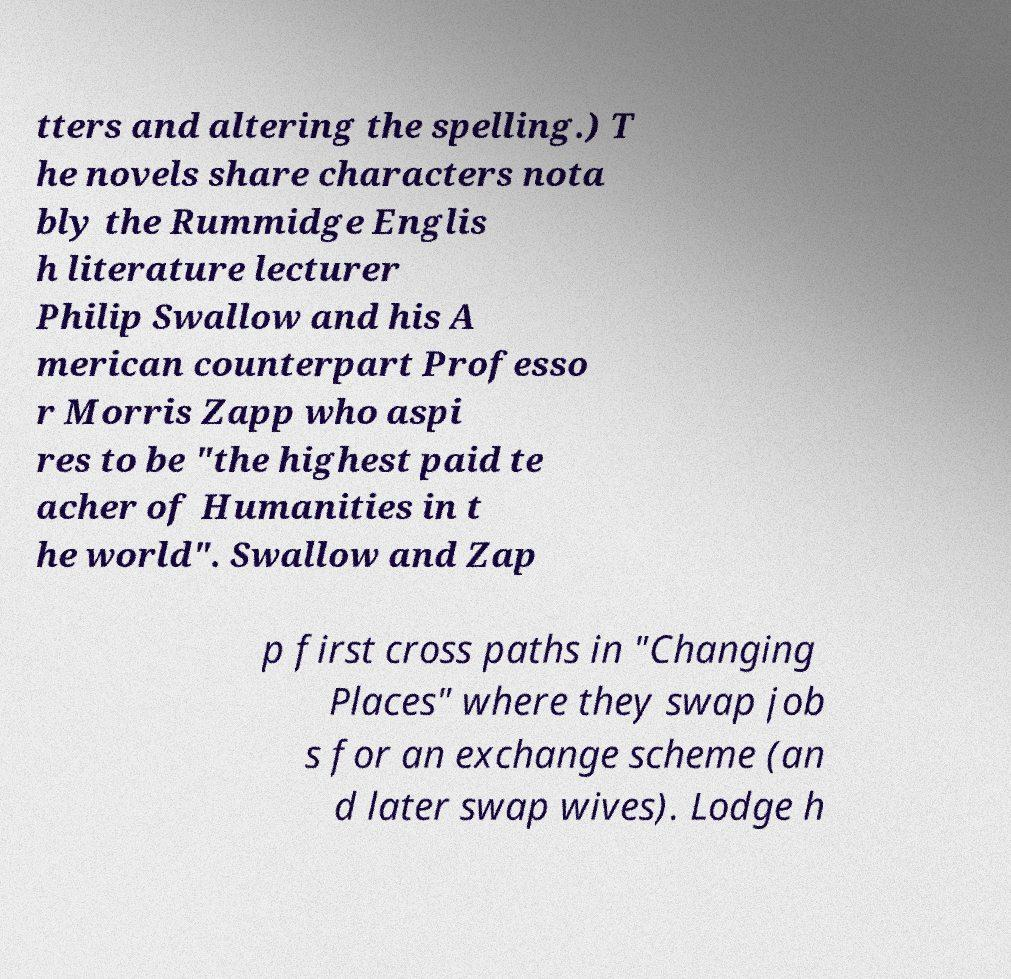Please read and relay the text visible in this image. What does it say? tters and altering the spelling.) T he novels share characters nota bly the Rummidge Englis h literature lecturer Philip Swallow and his A merican counterpart Professo r Morris Zapp who aspi res to be "the highest paid te acher of Humanities in t he world". Swallow and Zap p first cross paths in "Changing Places" where they swap job s for an exchange scheme (an d later swap wives). Lodge h 